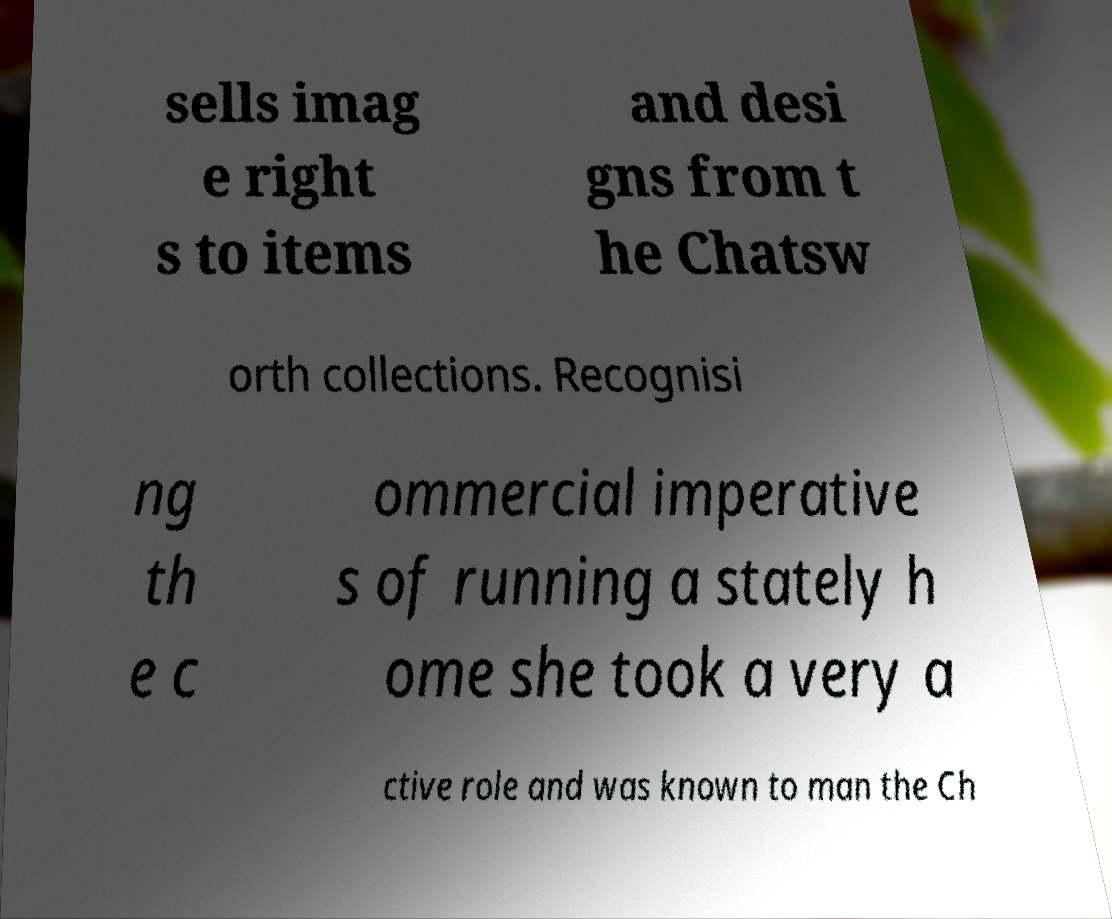Could you extract and type out the text from this image? sells imag e right s to items and desi gns from t he Chatsw orth collections. Recognisi ng th e c ommercial imperative s of running a stately h ome she took a very a ctive role and was known to man the Ch 